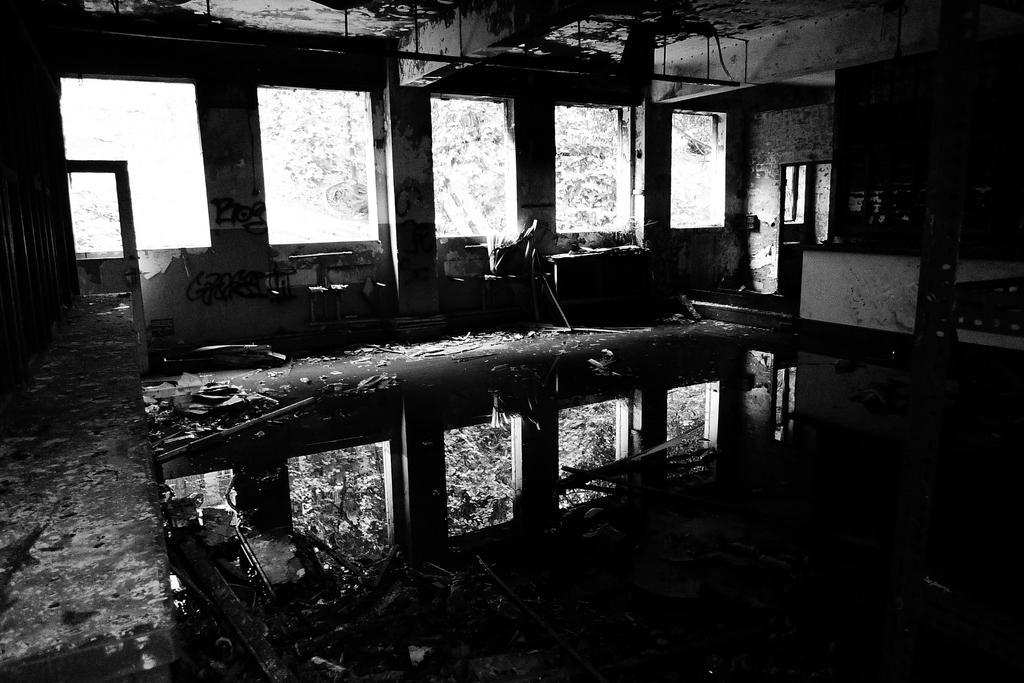In one or two sentences, can you explain what this image depicts? This is a black and white picture, in this image we can see an inside view of the building, there are some windows, pillars and some other objects. 